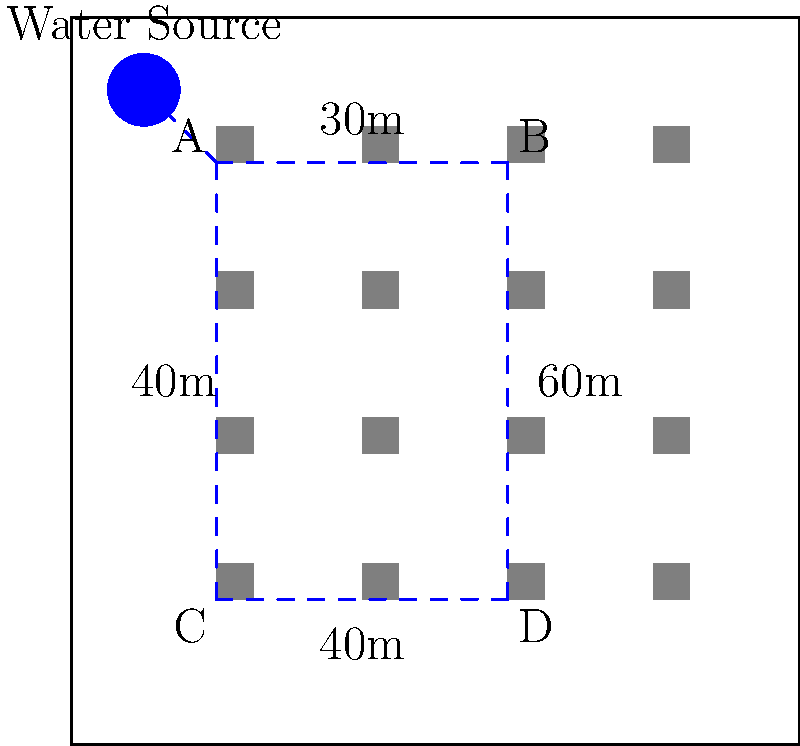In a small town, you need to design an efficient water distribution network. The town has a single water source and 16 houses arranged in a 4x4 grid. You can connect the houses using pipes along the grid lines. The distances between key points are shown in the diagram. What is the minimum total length of pipes (in meters) needed to connect all houses to the water source, assuming you can only lay pipes along the dashed lines shown? To solve this optimization problem, we'll use the concept of a minimum spanning tree. Here's the step-by-step approach:

1) First, identify the key points in the network:
   - Water Source
   - Point A (20,80)
   - Point B (60,80)
   - Point C (20,20)
   - Point D (60,20)

2) List the possible connections and their lengths:
   - Water Source to A: 10m + 10m = 20m
   - A to B: 30m
   - B to D: 60m
   - A to C: 60m
   - C to D: 40m

3) Apply Kruskal's algorithm to find the minimum spanning tree:
   a) Sort the connections by length:
      A to B: 30m
      C to D: 40m
      Water Source to A: 20m
      A to C: 60m or B to D: 60m (we'll need one of these)

   b) Add connections in order, avoiding cycles:
      - Add Water Source to A: 20m
      - Add A to B: 30m
      - Add C to D: 40m
      - Add A to C: 60m (choosing this over B to D as it connects all points)

4) Sum up the lengths of the chosen connections:
   20m + 30m + 40m + 60m = 150m

Therefore, the minimum total length of pipes needed is 150 meters.
Answer: 150 meters 